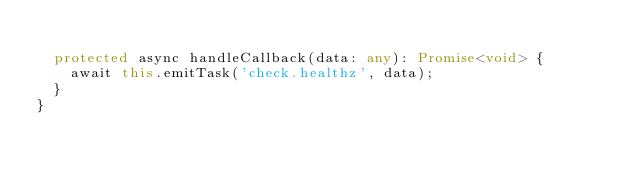Convert code to text. <code><loc_0><loc_0><loc_500><loc_500><_TypeScript_>
  protected async handleCallback(data: any): Promise<void> {
    await this.emitTask('check.healthz', data);
  }
}</code> 